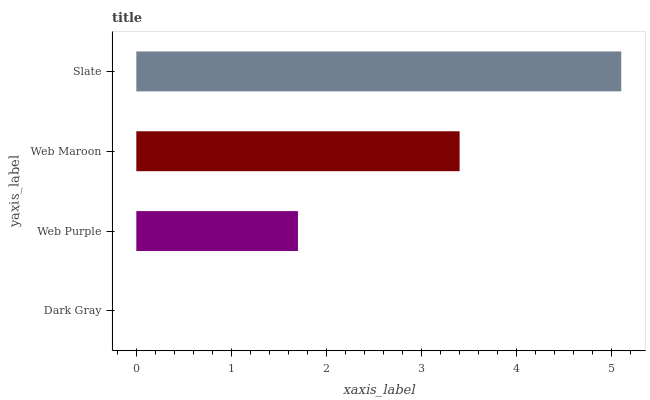Is Dark Gray the minimum?
Answer yes or no. Yes. Is Slate the maximum?
Answer yes or no. Yes. Is Web Purple the minimum?
Answer yes or no. No. Is Web Purple the maximum?
Answer yes or no. No. Is Web Purple greater than Dark Gray?
Answer yes or no. Yes. Is Dark Gray less than Web Purple?
Answer yes or no. Yes. Is Dark Gray greater than Web Purple?
Answer yes or no. No. Is Web Purple less than Dark Gray?
Answer yes or no. No. Is Web Maroon the high median?
Answer yes or no. Yes. Is Web Purple the low median?
Answer yes or no. Yes. Is Dark Gray the high median?
Answer yes or no. No. Is Web Maroon the low median?
Answer yes or no. No. 